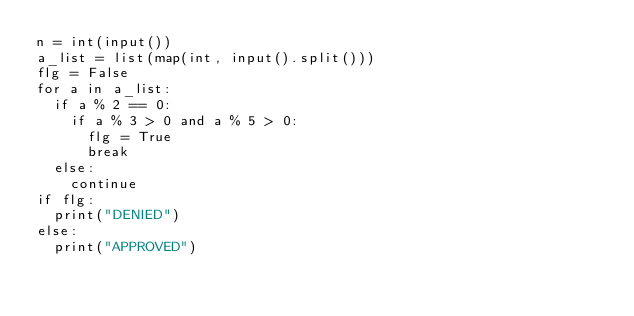<code> <loc_0><loc_0><loc_500><loc_500><_Python_>n = int(input())
a_list = list(map(int, input().split()))
flg = False
for a in a_list:
  if a % 2 == 0:
    if a % 3 > 0 and a % 5 > 0:
      flg = True
      break
  else:
    continue
if flg:
  print("DENIED")
else:
  print("APPROVED")</code> 